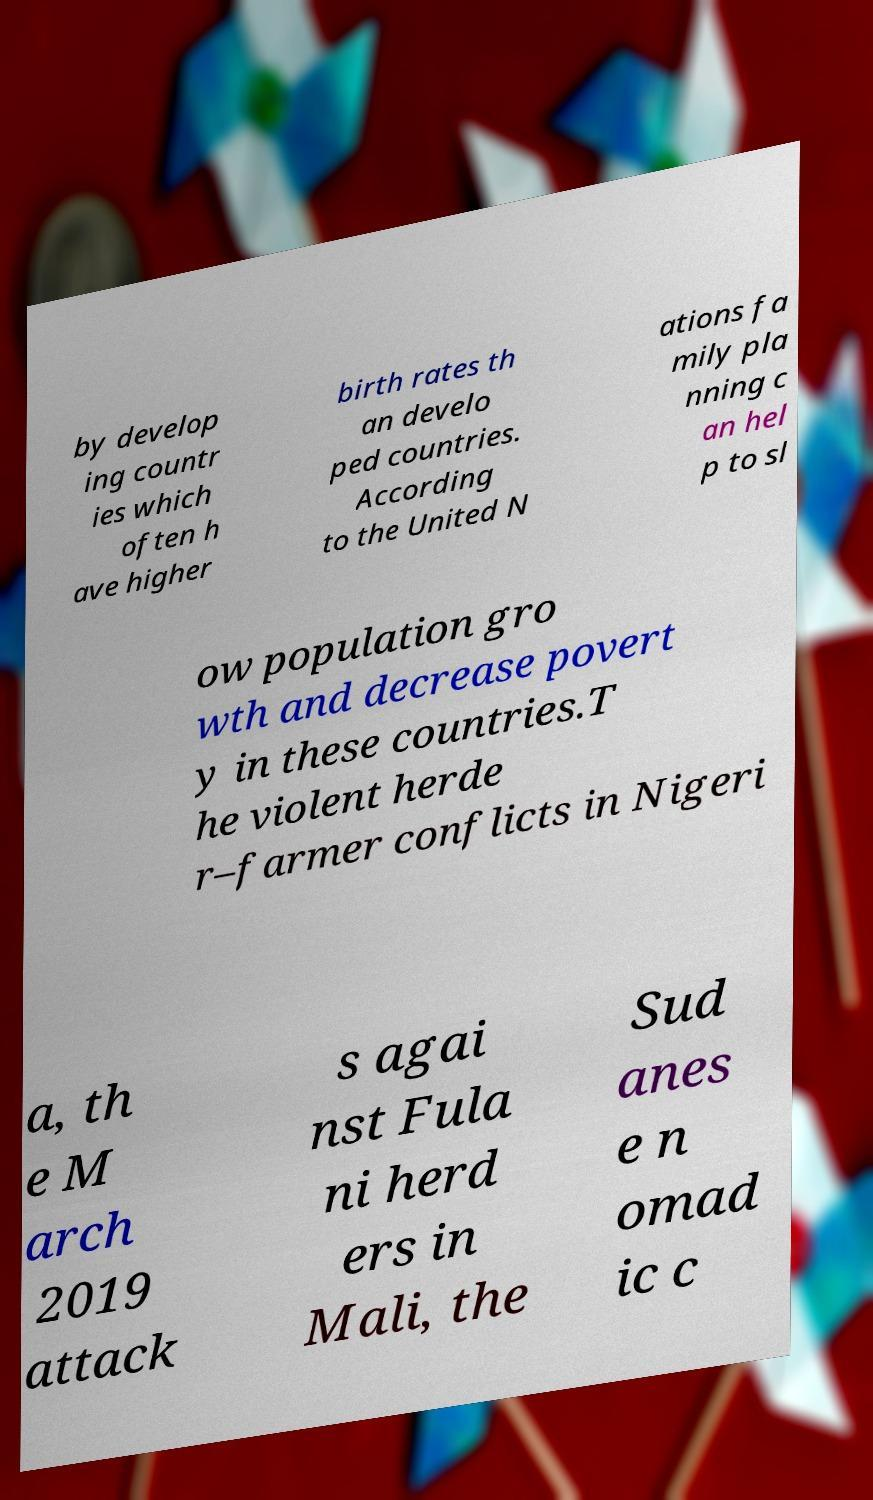There's text embedded in this image that I need extracted. Can you transcribe it verbatim? by develop ing countr ies which often h ave higher birth rates th an develo ped countries. According to the United N ations fa mily pla nning c an hel p to sl ow population gro wth and decrease povert y in these countries.T he violent herde r–farmer conflicts in Nigeri a, th e M arch 2019 attack s agai nst Fula ni herd ers in Mali, the Sud anes e n omad ic c 